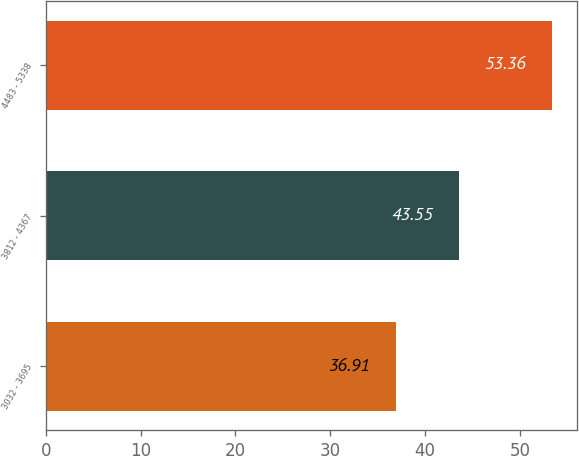Convert chart. <chart><loc_0><loc_0><loc_500><loc_500><bar_chart><fcel>3032 - 3695<fcel>3812 - 4367<fcel>4483 - 5338<nl><fcel>36.91<fcel>43.55<fcel>53.36<nl></chart> 